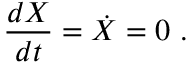<formula> <loc_0><loc_0><loc_500><loc_500>{ \frac { d X } { d t } } = { \dot { X } } = 0 .</formula> 